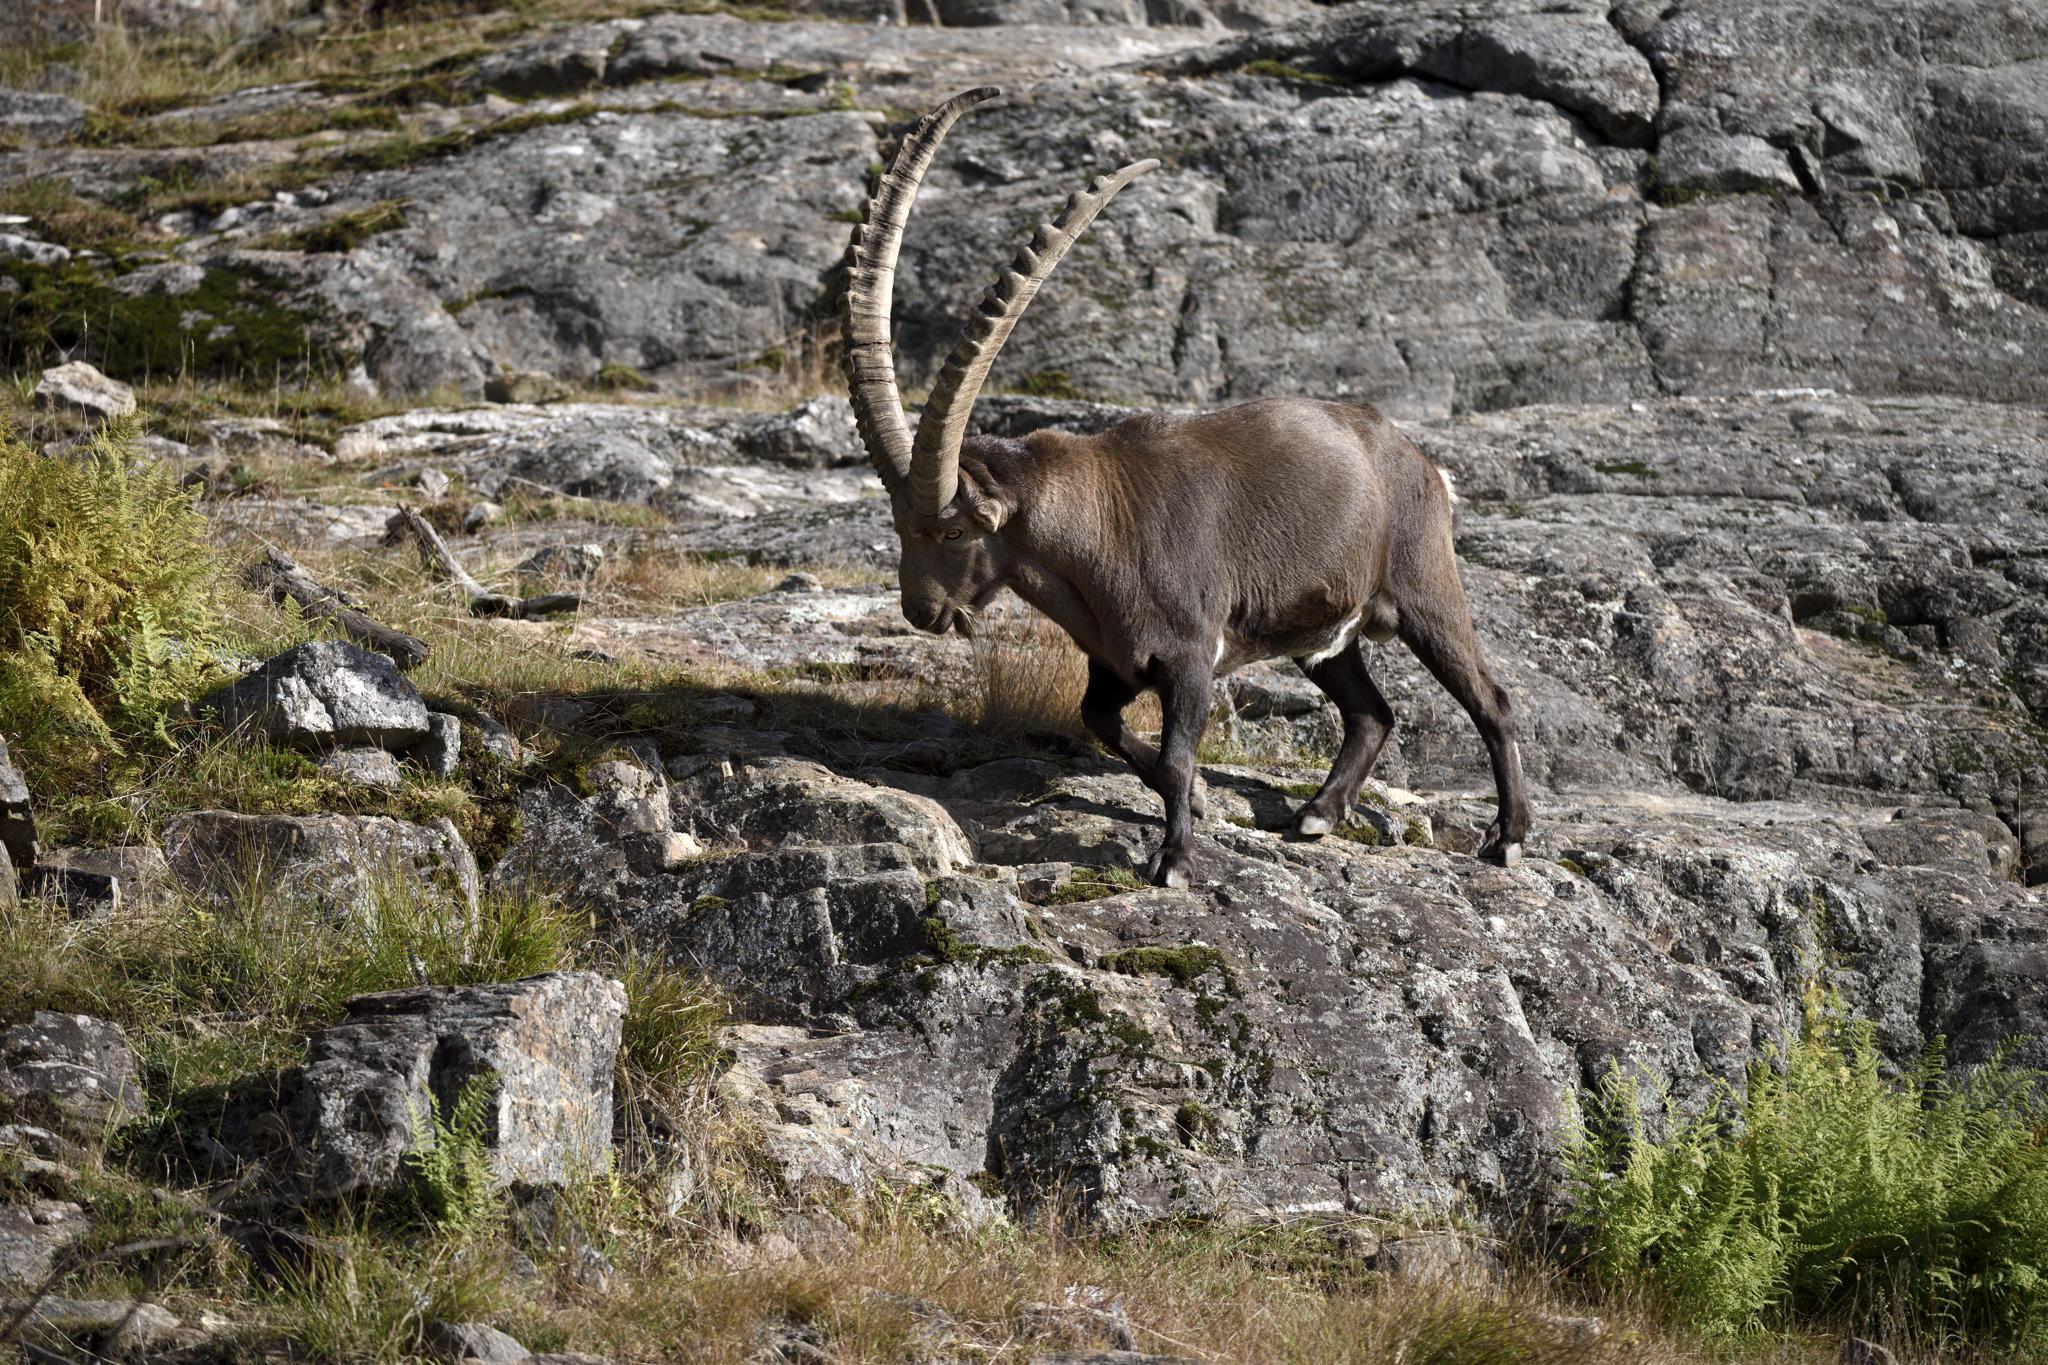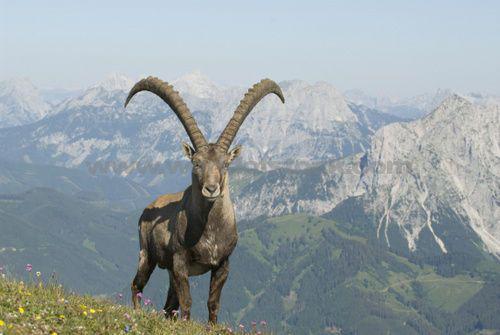The first image is the image on the left, the second image is the image on the right. Given the left and right images, does the statement "There are three goat-type animals on rocks." hold true? Answer yes or no. No. 